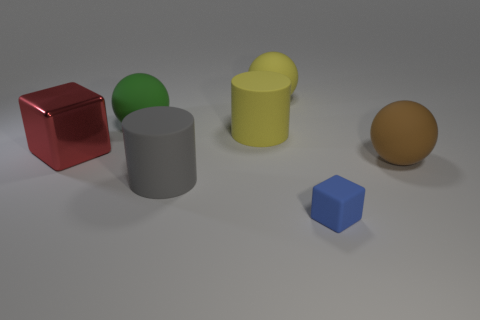How many green things are large metallic balls or big things?
Give a very brief answer. 1. How many brown metallic blocks are the same size as the yellow ball?
Your answer should be compact. 0. The large rubber ball that is both in front of the large yellow ball and on the left side of the brown rubber object is what color?
Your answer should be very brief. Green. Is the number of large spheres on the left side of the large yellow cylinder greater than the number of tiny cubes?
Keep it short and to the point. No. Are any tiny blue objects visible?
Ensure brevity in your answer.  Yes. Is the big metal object the same color as the tiny block?
Offer a terse response. No. What number of large things are red blocks or rubber spheres?
Provide a short and direct response. 4. Is there any other thing that is the same color as the rubber cube?
Give a very brief answer. No. What shape is the blue thing that is made of the same material as the big yellow sphere?
Your answer should be compact. Cube. There is a yellow object that is behind the green matte thing; what is its size?
Your answer should be compact. Large. 